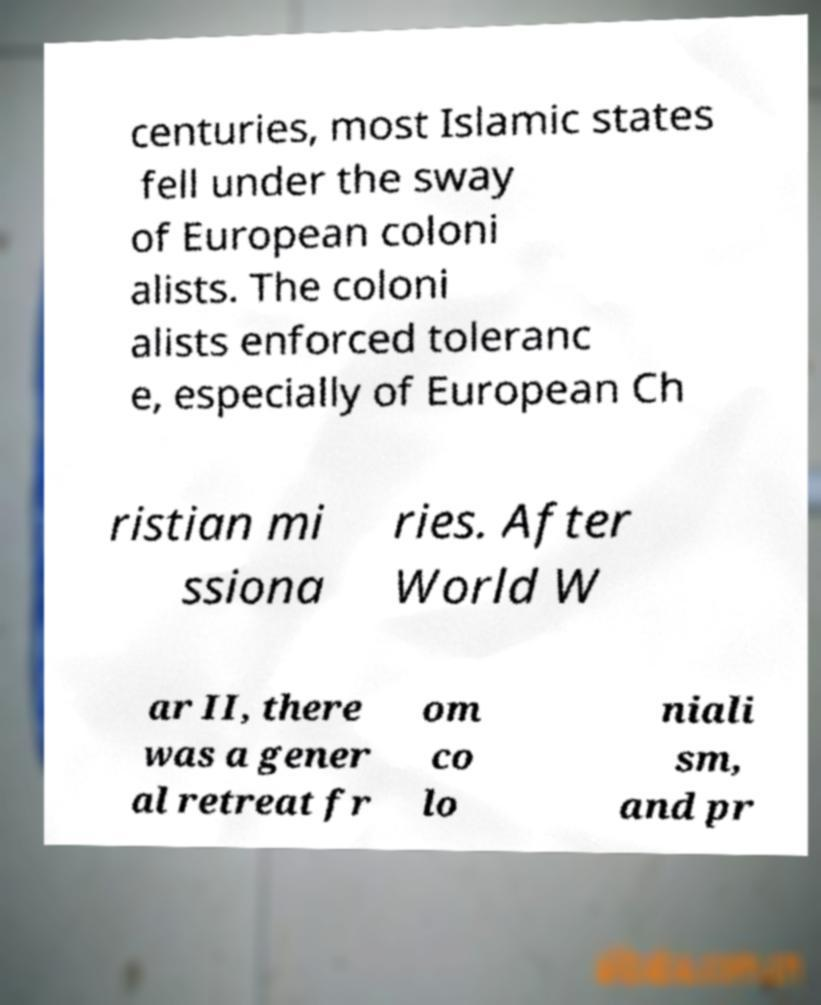I need the written content from this picture converted into text. Can you do that? centuries, most Islamic states fell under the sway of European coloni alists. The coloni alists enforced toleranc e, especially of European Ch ristian mi ssiona ries. After World W ar II, there was a gener al retreat fr om co lo niali sm, and pr 